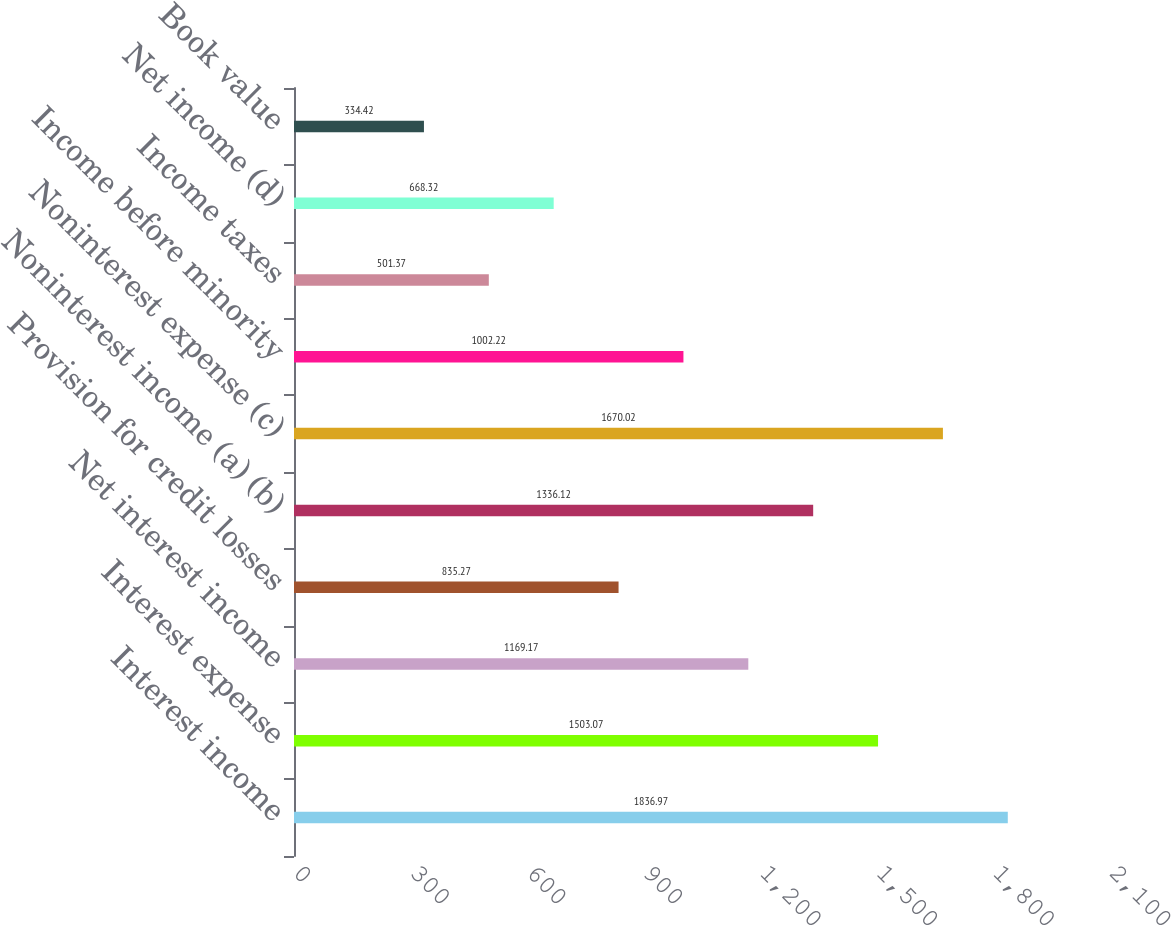<chart> <loc_0><loc_0><loc_500><loc_500><bar_chart><fcel>Interest income<fcel>Interest expense<fcel>Net interest income<fcel>Provision for credit losses<fcel>Noninterest income (a) (b)<fcel>Noninterest expense (c)<fcel>Income before minority<fcel>Income taxes<fcel>Net income (d)<fcel>Book value<nl><fcel>1836.97<fcel>1503.07<fcel>1169.17<fcel>835.27<fcel>1336.12<fcel>1670.02<fcel>1002.22<fcel>501.37<fcel>668.32<fcel>334.42<nl></chart> 